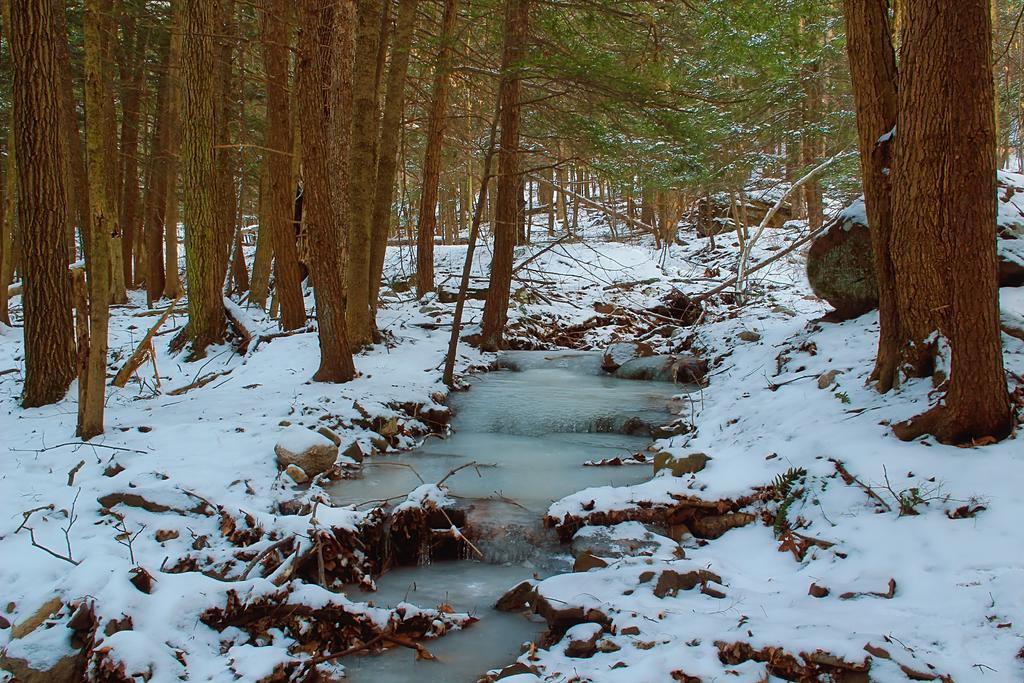What is the primary natural element present in the image? There is snow in the image. What type of vegetation can be seen in the image? There are trees in the image. What is the water feature visible in the image? There is a water flow visible in the image. What type of cable can be seen running through the snow in the image? There is no cable present in the image; it only features snow, trees, and a water flow. 